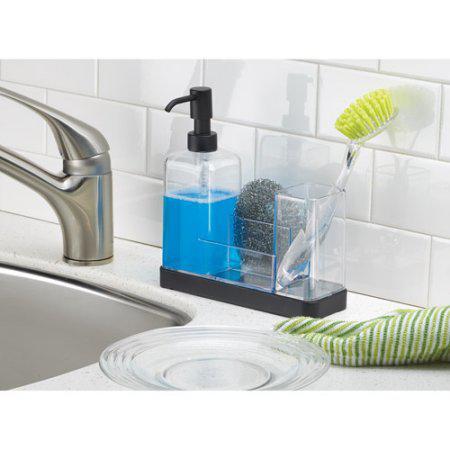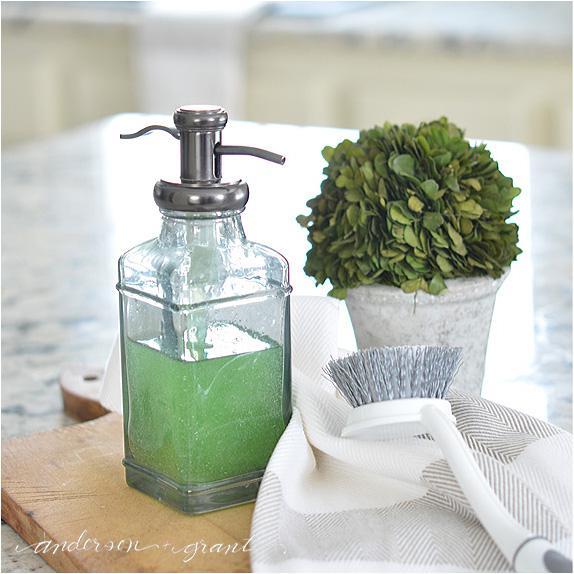The first image is the image on the left, the second image is the image on the right. For the images displayed, is the sentence "An image shows a pump dispenser containing a blue liquid." factually correct? Answer yes or no. Yes. The first image is the image on the left, the second image is the image on the right. Assess this claim about the two images: "There is blue liquid visible inside a clear soap dispenser". Correct or not? Answer yes or no. Yes. 